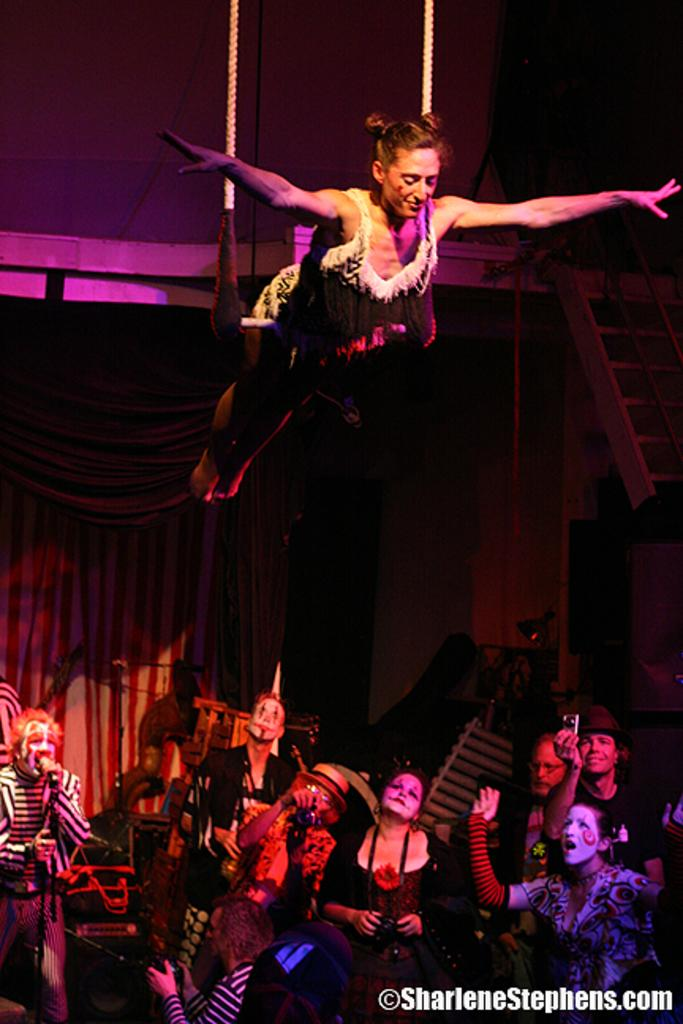What is happening with the women in the image? The women are in the air in the image. Can you describe the people visible in the image? Yes, there are people visible in the image. What type of letter is being delivered by the yak in the image? There is no yak or letter present in the image; it features women in the air. 